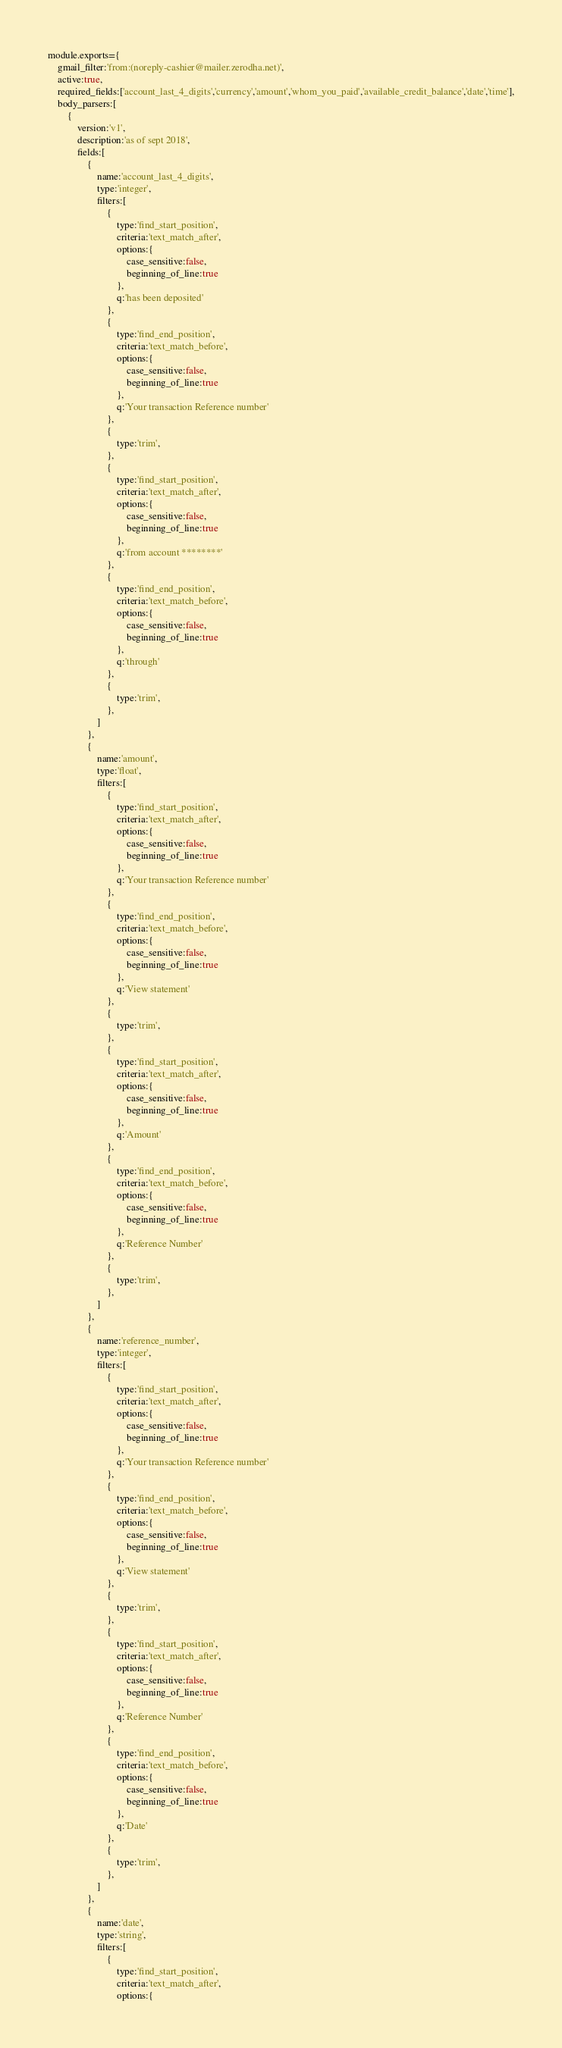Convert code to text. <code><loc_0><loc_0><loc_500><loc_500><_JavaScript_>module.exports={
	gmail_filter:'from:(noreply-cashier@mailer.zerodha.net)',
	active:true,
	required_fields:['account_last_4_digits','currency','amount','whom_you_paid','available_credit_balance','date','time'],
	body_parsers:[
		{
			version:'v1',
			description:'as of sept 2018',
			fields:[
				{
					name:'account_last_4_digits',
					type:'integer',
					filters:[
						{
							type:'find_start_position',
							criteria:'text_match_after',
							options:{
								case_sensitive:false,
								beginning_of_line:true
							},
							q:'has been deposited'
						},
						{
							type:'find_end_position',
							criteria:'text_match_before',
							options:{
								case_sensitive:false,
								beginning_of_line:true
							},
							q:'Your transaction Reference number'
						},
						{
							type:'trim',
						},
						{
							type:'find_start_position',
							criteria:'text_match_after',
							options:{
								case_sensitive:false,
								beginning_of_line:true
							},
							q:'from account ********'
						},
						{
							type:'find_end_position',
							criteria:'text_match_before',
							options:{
								case_sensitive:false,
								beginning_of_line:true
							},
							q:'through'
						},
						{
							type:'trim',
						},
					]
				},
				{
					name:'amount',
					type:'float',
					filters:[
						{
							type:'find_start_position',
							criteria:'text_match_after',
							options:{
								case_sensitive:false,
								beginning_of_line:true
							},
							q:'Your transaction Reference number'
						},
						{
							type:'find_end_position',
							criteria:'text_match_before',
							options:{
								case_sensitive:false,
								beginning_of_line:true
							},
							q:'View statement'
						},
						{
							type:'trim',
						},
						{
							type:'find_start_position',
							criteria:'text_match_after',
							options:{
								case_sensitive:false,
								beginning_of_line:true
							},
							q:'Amount'
						},
						{
							type:'find_end_position',
							criteria:'text_match_before',
							options:{
								case_sensitive:false,
								beginning_of_line:true
							},
							q:'Reference Number'
						},
						{
							type:'trim',
						},
					]
				},
				{
					name:'reference_number',
					type:'integer',
					filters:[
						{
							type:'find_start_position',
							criteria:'text_match_after',
							options:{
								case_sensitive:false,
								beginning_of_line:true
							},
							q:'Your transaction Reference number'
						},
						{
							type:'find_end_position',
							criteria:'text_match_before',
							options:{
								case_sensitive:false,
								beginning_of_line:true
							},
							q:'View statement'
						},
						{
							type:'trim',
						},
						{
							type:'find_start_position',
							criteria:'text_match_after',
							options:{
								case_sensitive:false,
								beginning_of_line:true
							},
							q:'Reference Number'
						},
						{
							type:'find_end_position',
							criteria:'text_match_before',
							options:{
								case_sensitive:false,
								beginning_of_line:true
							},
							q:'Date'
						},
						{
							type:'trim',
						},
					]
				},
				{
					name:'date',
					type:'string',
					filters:[
						{
							type:'find_start_position',
							criteria:'text_match_after',
							options:{</code> 